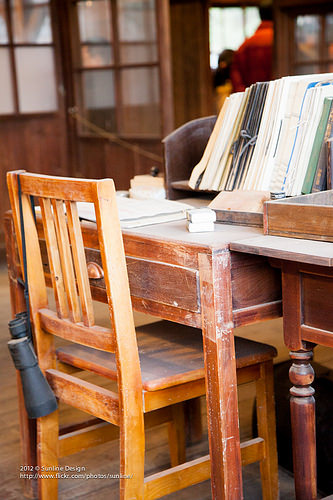<image>
Can you confirm if the chair is in front of the desk? Yes. The chair is positioned in front of the desk, appearing closer to the camera viewpoint. 